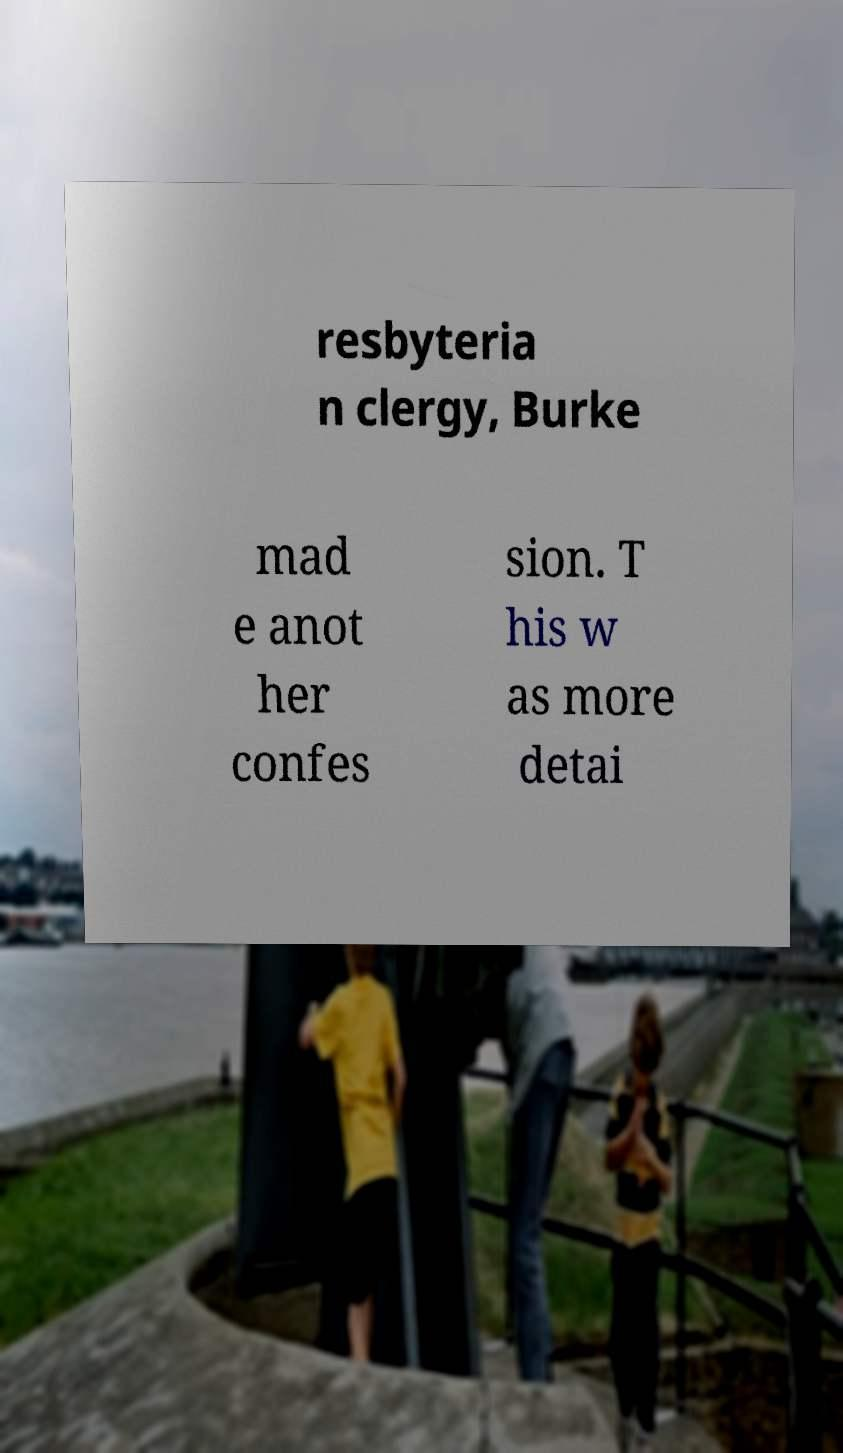For documentation purposes, I need the text within this image transcribed. Could you provide that? resbyteria n clergy, Burke mad e anot her confes sion. T his w as more detai 